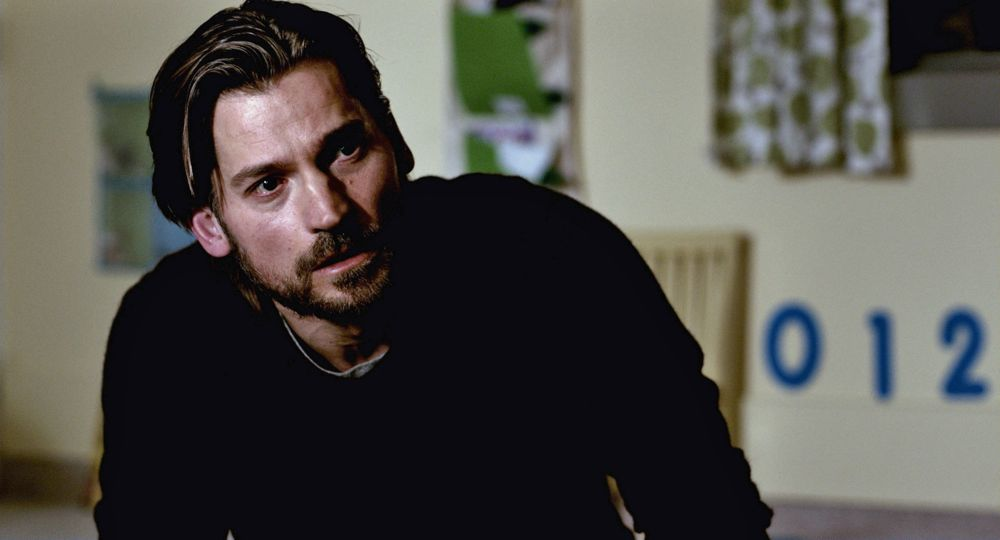Explain the visual content of the image in great detail. The image features a middle-aged man with a beard and medium-length hair. He is seated in a subdued environment, possibly an office or a home room, indicated by a simple, mostly bare green wall behind him. On the wall, a visible portion of a whiteboard with the number '012' can be seen. The man is wearing a dark sweater and appears to be in a reflective or thoughtful mood, staring slightly off-camera, which suggests that he is either lost in thought or engrossed in a serene moment. His expression is serious and contemplative. 